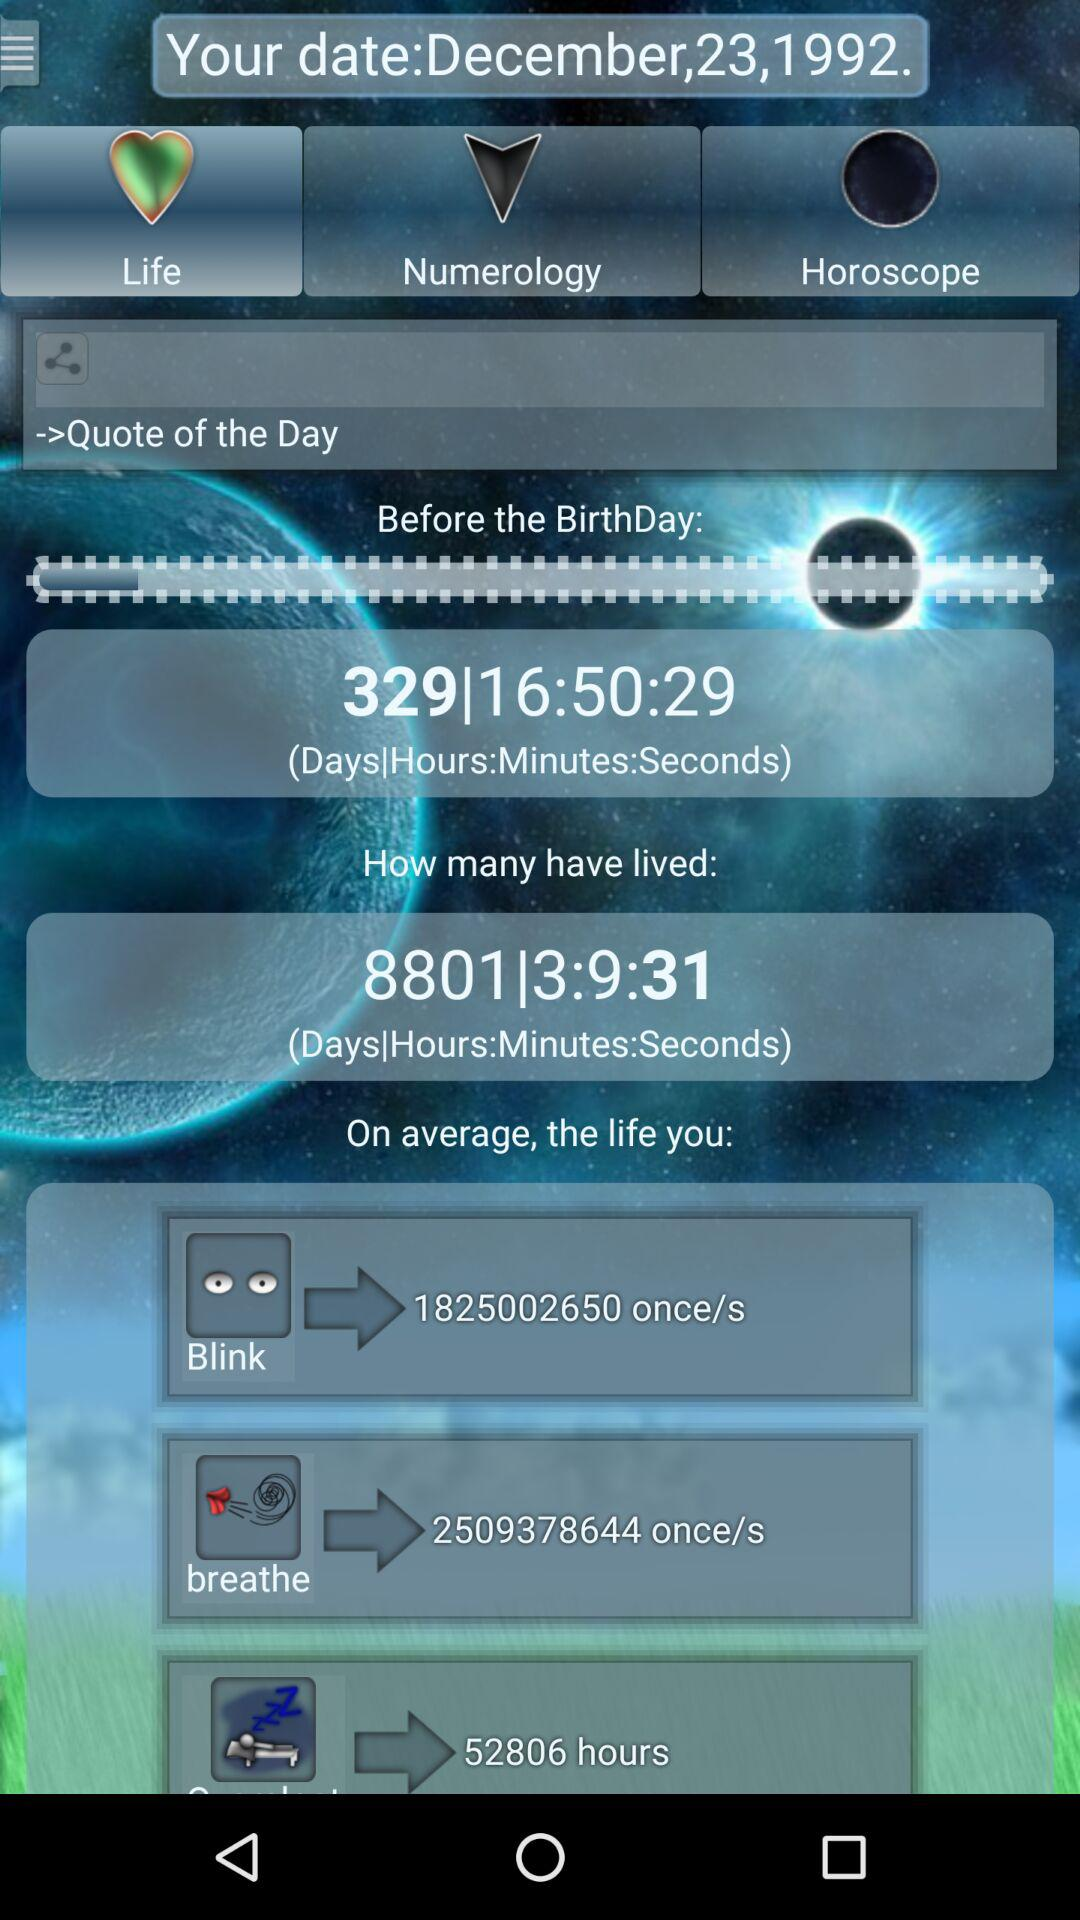What is the selected tab? The selected tab is "Life". 